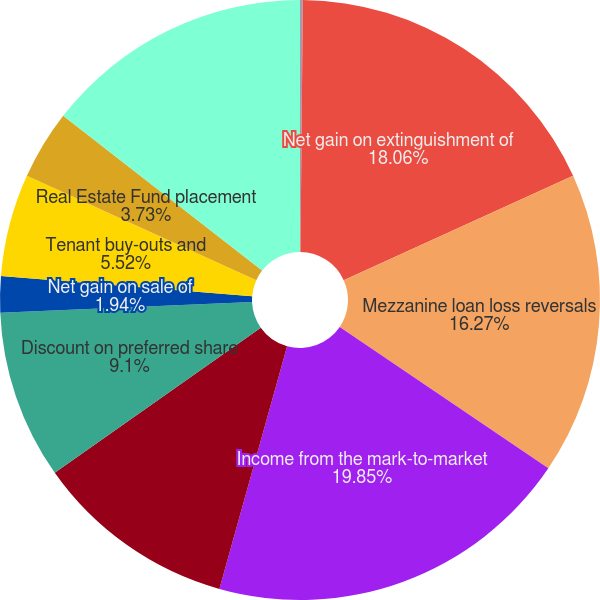Convert chart to OTSL. <chart><loc_0><loc_0><loc_500><loc_500><pie_chart><fcel>(Amounts in thousands)<fcel>Net gain on extinguishment of<fcel>Mezzanine loan loss reversals<fcel>Income from the mark-to-market<fcel>Net gain resulting from<fcel>Discount on preferred share<fcel>Net gain on sale of<fcel>Tenant buy-outs and<fcel>Real Estate Fund placement<fcel>FFO attributable to<nl><fcel>0.15%<fcel>18.06%<fcel>16.27%<fcel>19.85%<fcel>10.9%<fcel>9.1%<fcel>1.94%<fcel>5.52%<fcel>3.73%<fcel>14.48%<nl></chart> 